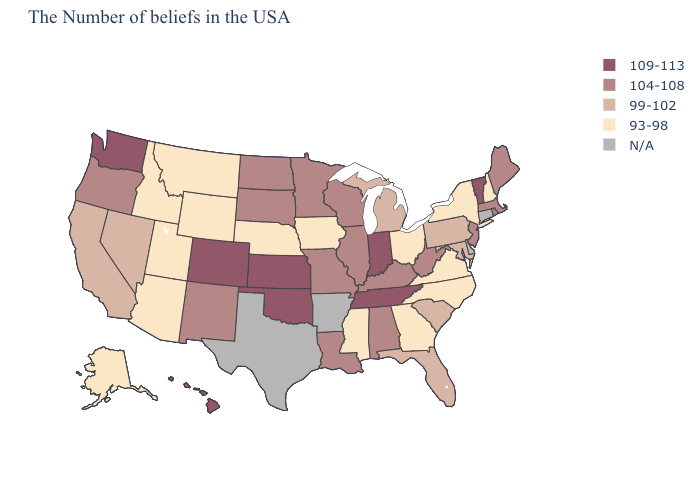Among the states that border New Hampshire , does Vermont have the highest value?
Concise answer only. Yes. Does the first symbol in the legend represent the smallest category?
Write a very short answer. No. Is the legend a continuous bar?
Concise answer only. No. Among the states that border Arkansas , which have the lowest value?
Quick response, please. Mississippi. How many symbols are there in the legend?
Keep it brief. 5. Name the states that have a value in the range 109-113?
Write a very short answer. Vermont, Indiana, Tennessee, Kansas, Oklahoma, Colorado, Washington, Hawaii. What is the value of Mississippi?
Write a very short answer. 93-98. What is the value of New Hampshire?
Quick response, please. 93-98. Does Washington have the highest value in the West?
Concise answer only. Yes. Does the first symbol in the legend represent the smallest category?
Concise answer only. No. What is the lowest value in the USA?
Give a very brief answer. 93-98. What is the value of Alaska?
Short answer required. 93-98. 